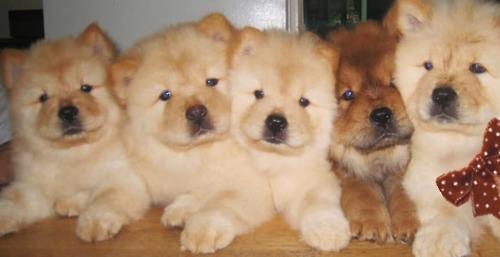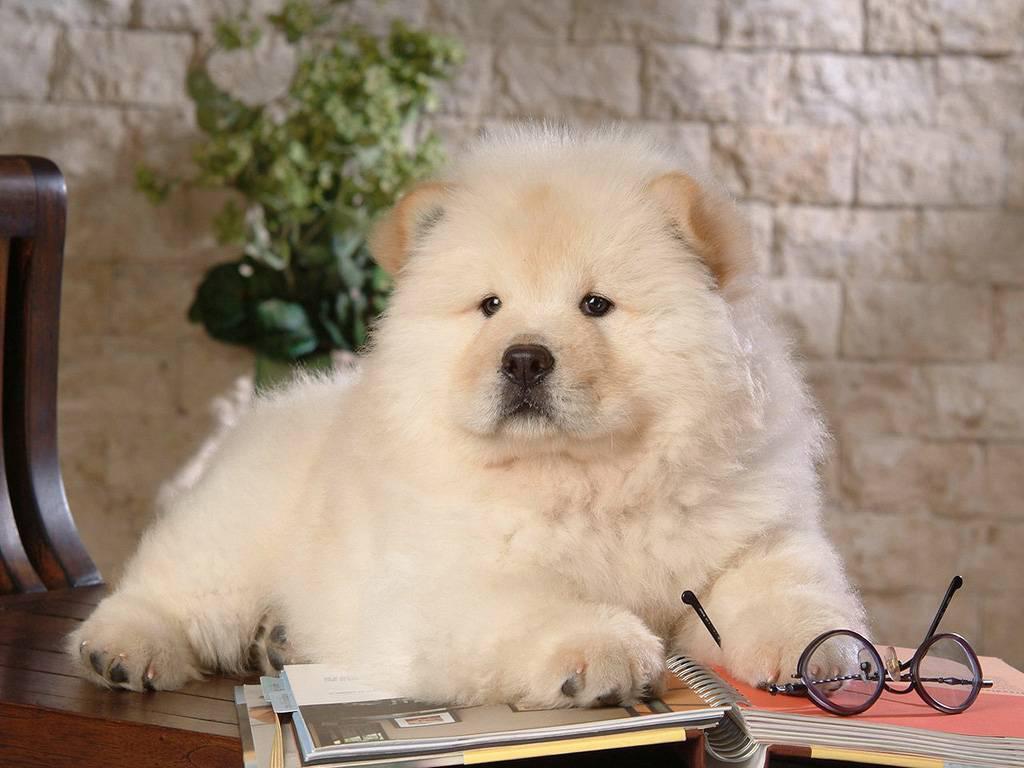The first image is the image on the left, the second image is the image on the right. Evaluate the accuracy of this statement regarding the images: "One of the images contains at least three dogs.". Is it true? Answer yes or no. Yes. 